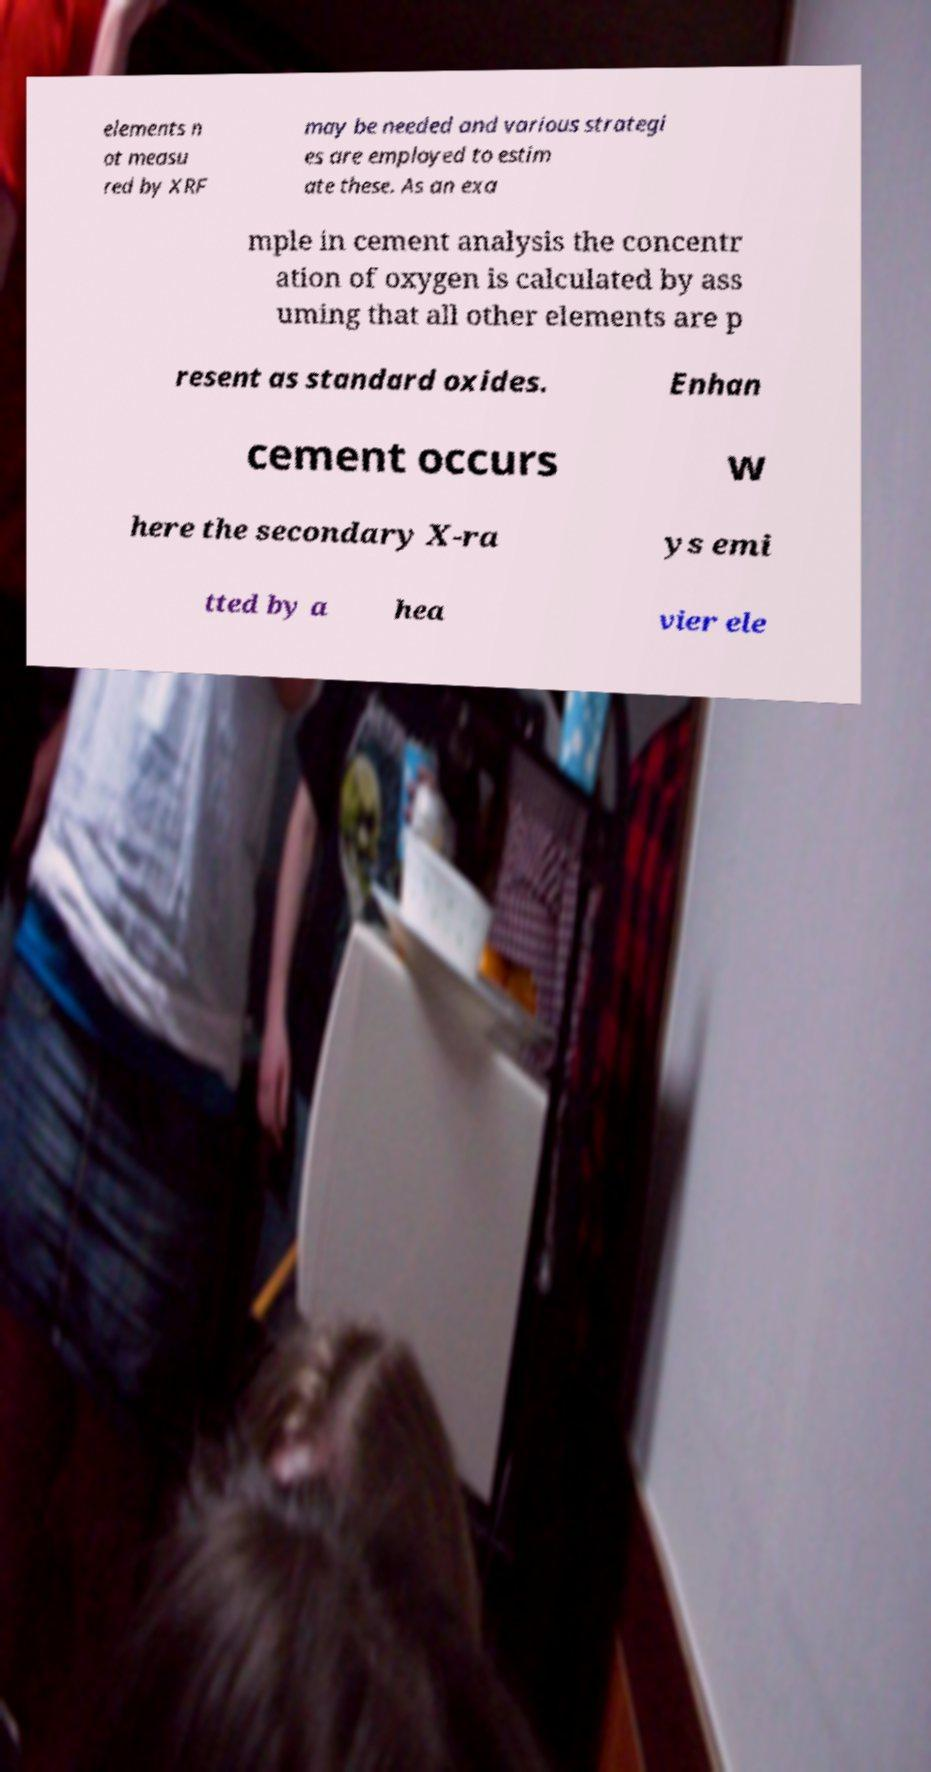Please identify and transcribe the text found in this image. elements n ot measu red by XRF may be needed and various strategi es are employed to estim ate these. As an exa mple in cement analysis the concentr ation of oxygen is calculated by ass uming that all other elements are p resent as standard oxides. Enhan cement occurs w here the secondary X-ra ys emi tted by a hea vier ele 